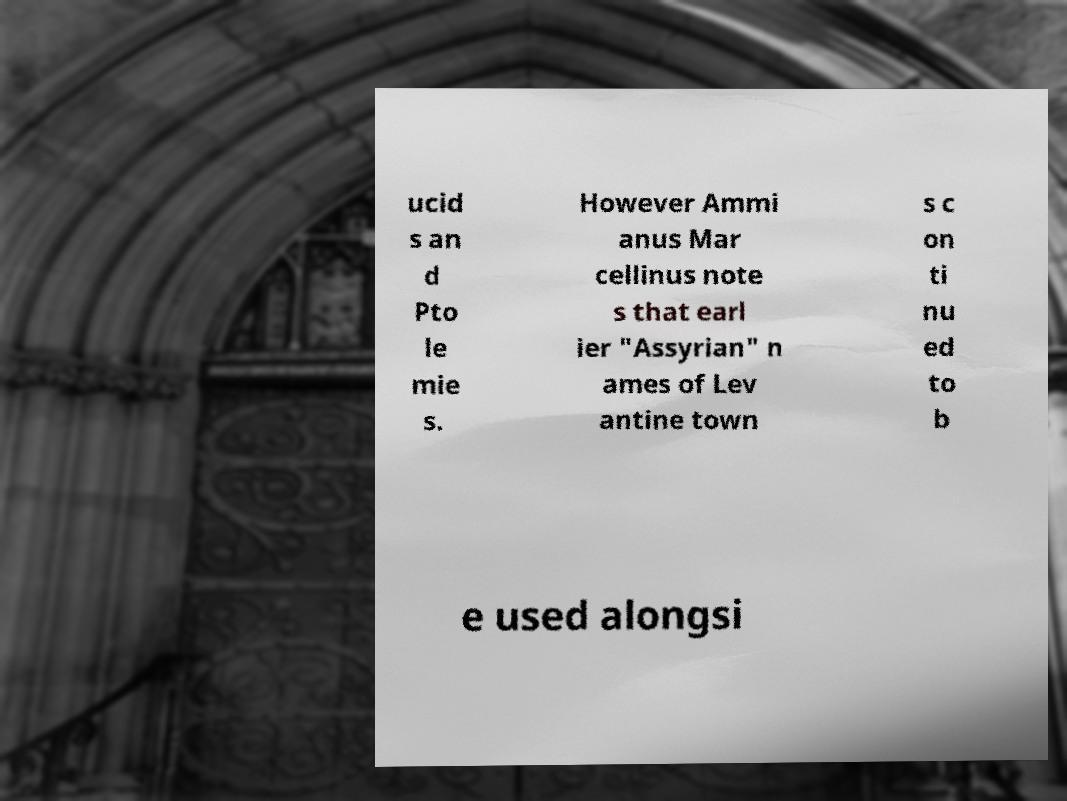There's text embedded in this image that I need extracted. Can you transcribe it verbatim? ucid s an d Pto le mie s. However Ammi anus Mar cellinus note s that earl ier "Assyrian" n ames of Lev antine town s c on ti nu ed to b e used alongsi 